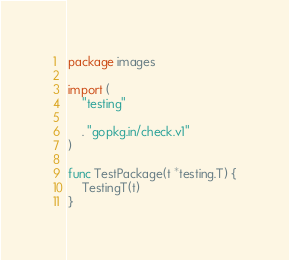Convert code to text. <code><loc_0><loc_0><loc_500><loc_500><_Go_>package images

import (
	"testing"

	. "gopkg.in/check.v1"
)

func TestPackage(t *testing.T) {
	TestingT(t)
}
</code> 